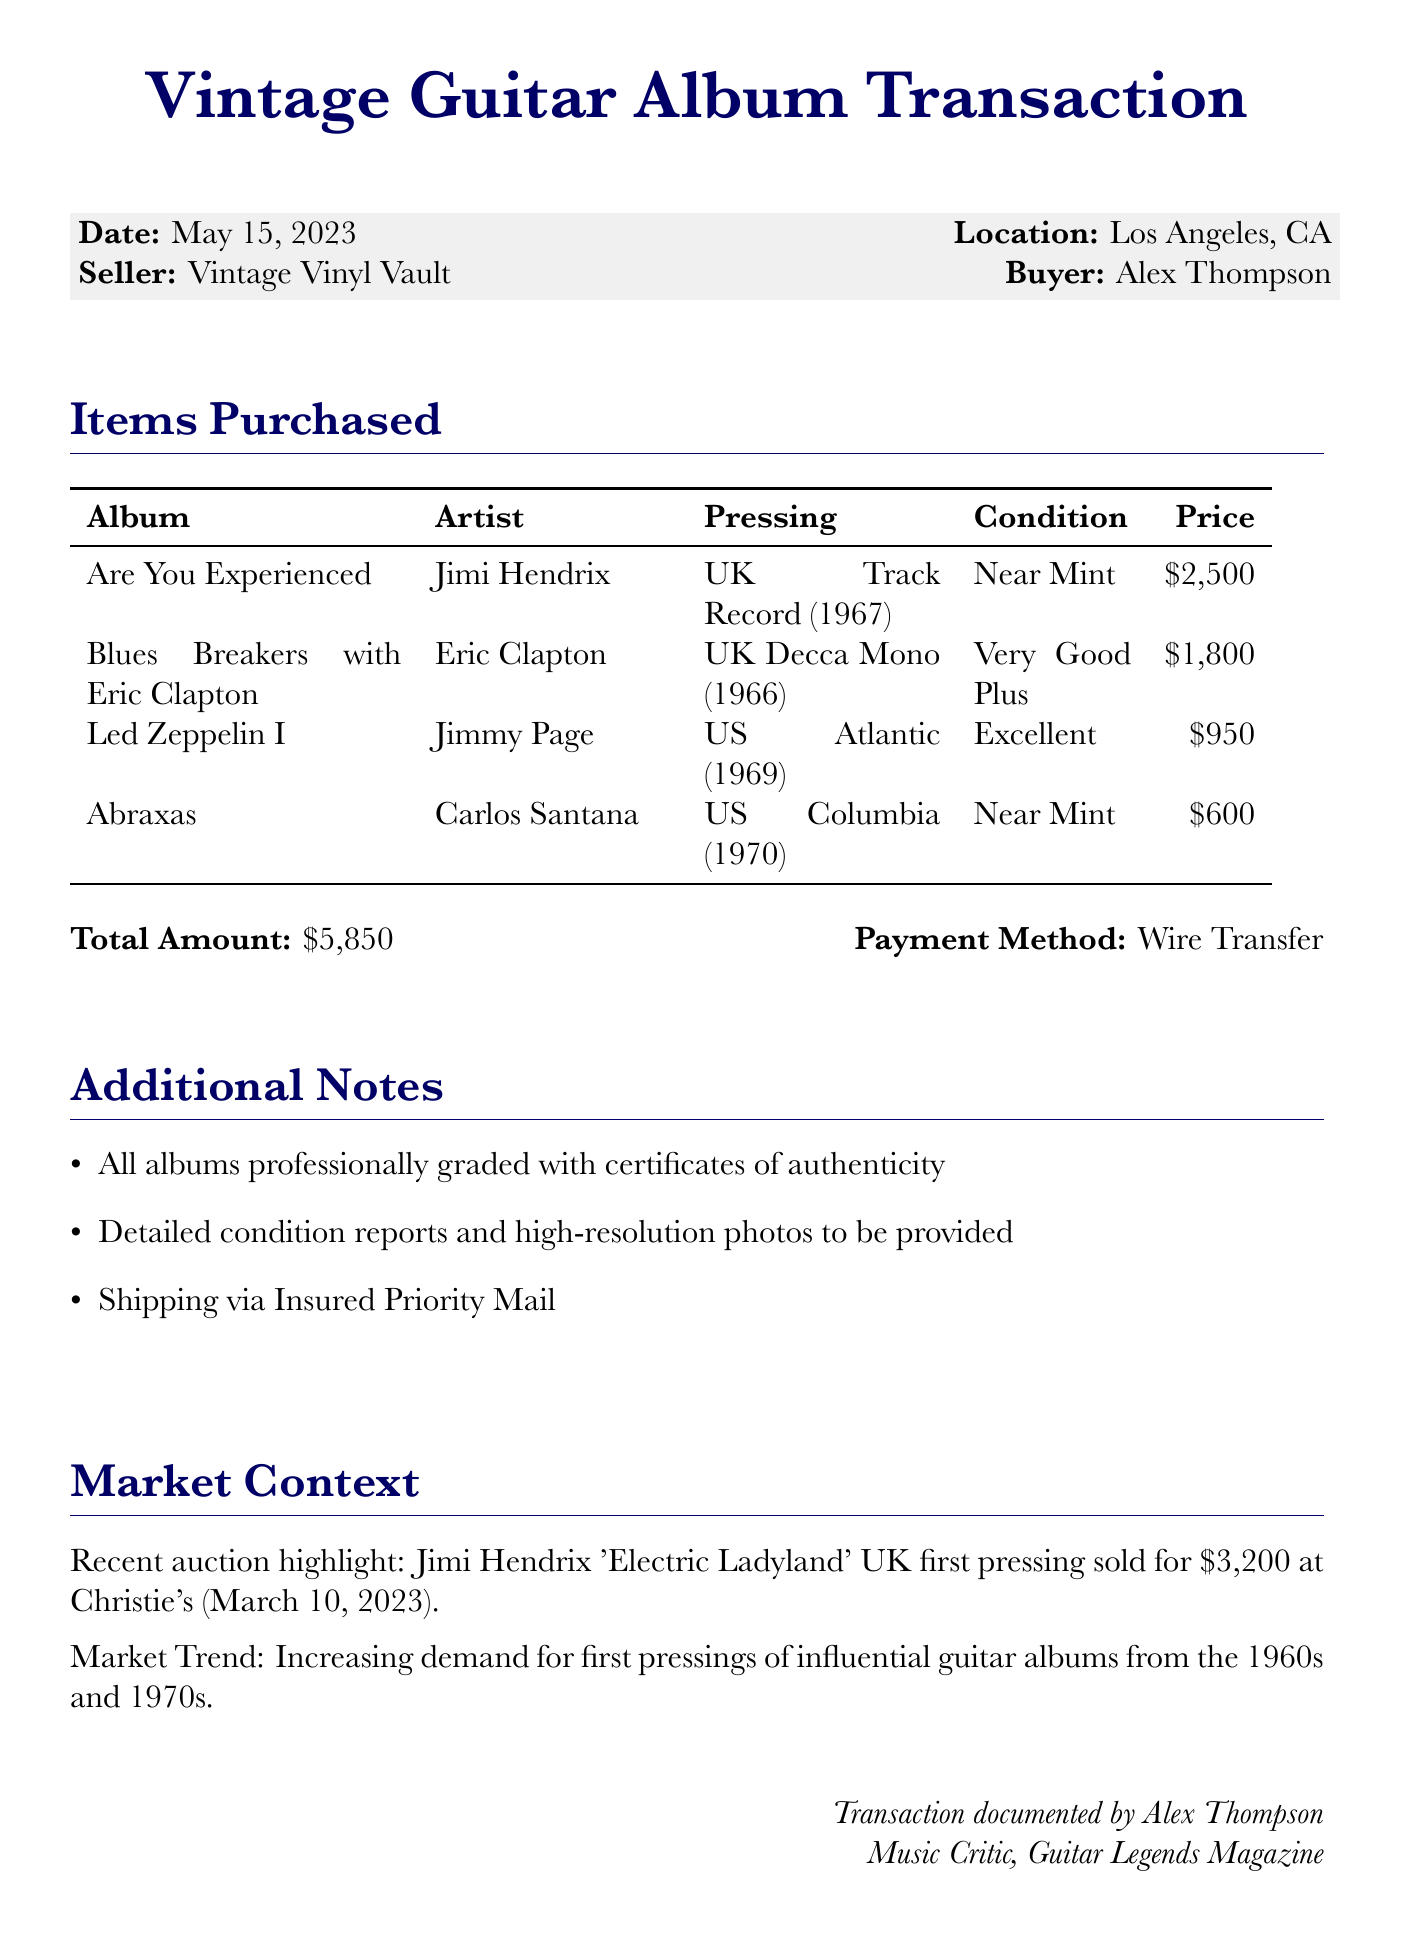What is the date of the transaction? The date of the transaction is explicitly stated in the document.
Answer: May 15, 2023 Who is the seller of the albums? The seller's name is mentioned in the transaction details section.
Answer: Vintage Vinyl Vault What was the total amount of the transaction? The total amount is summarized in the document's payment section.
Answer: $5,850 What condition is the Jimi Hendrix album in? The condition of each album is listed alongside its details.
Answer: Near Mint Which payment method was used for the transaction? The payment method is stated in the transaction details.
Answer: Wire Transfer What is the notable sale mentioned in the recent auction? The document lists a specific notable sale in the market context section.
Answer: Jimi Hendrix 'Electric Ladyland' UK Track Record first pressing - $3,200 How many items were purchased in total? The total number of items purchased can be counted from the items_purchased section.
Answer: 4 What is the occupation of the buyer? The buyer's occupation is highlighted in the buyer_background section.
Answer: Music Critic How long has the seller been in business? The seller's years in business is captured in the seller_reputation section.
Answer: 25 years 